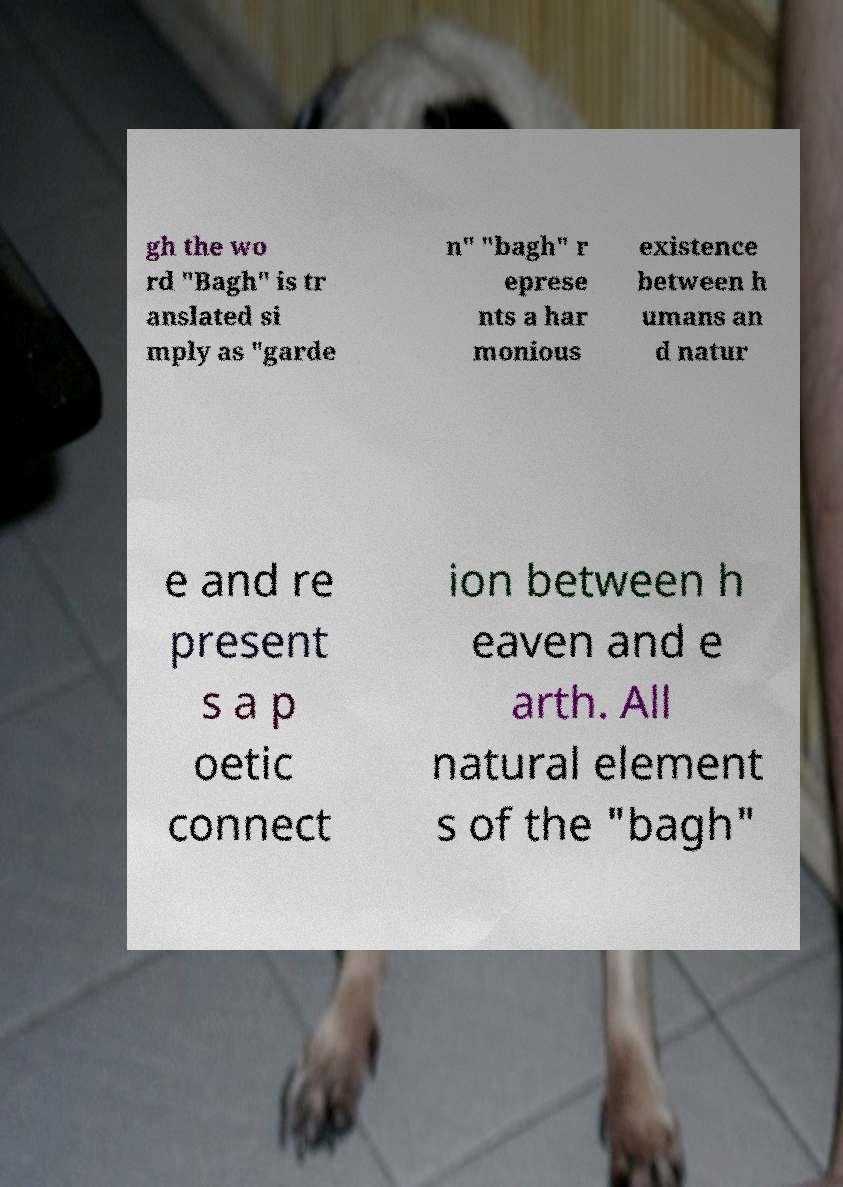Please read and relay the text visible in this image. What does it say? gh the wo rd "Bagh" is tr anslated si mply as "garde n" "bagh" r eprese nts a har monious existence between h umans an d natur e and re present s a p oetic connect ion between h eaven and e arth. All natural element s of the "bagh" 